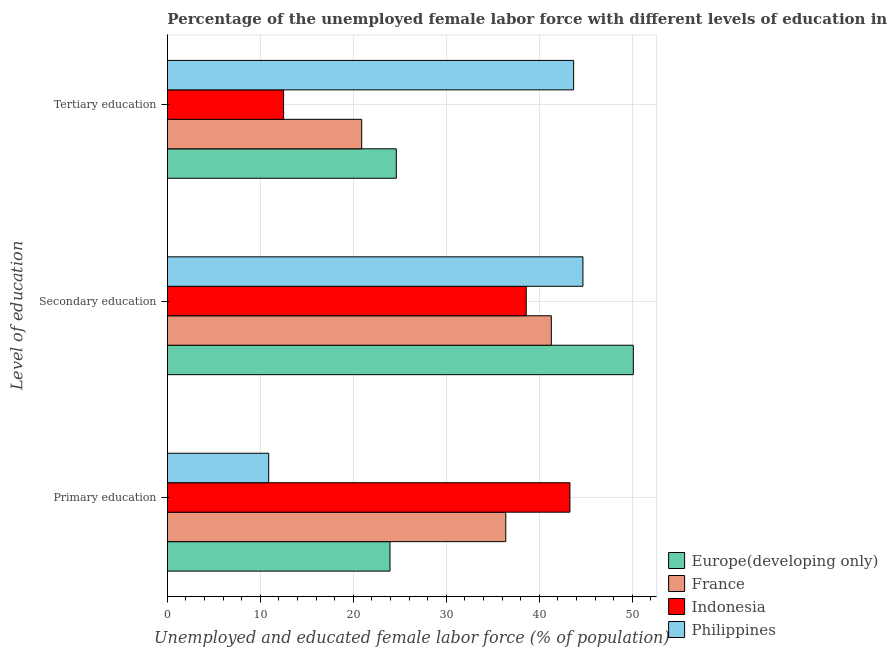Are the number of bars per tick equal to the number of legend labels?
Your answer should be compact. Yes. Are the number of bars on each tick of the Y-axis equal?
Offer a very short reply. Yes. How many bars are there on the 1st tick from the top?
Keep it short and to the point. 4. How many bars are there on the 2nd tick from the bottom?
Provide a short and direct response. 4. What is the label of the 1st group of bars from the top?
Give a very brief answer. Tertiary education. What is the percentage of female labor force who received secondary education in Indonesia?
Give a very brief answer. 38.6. Across all countries, what is the maximum percentage of female labor force who received secondary education?
Your response must be concise. 50.12. Across all countries, what is the minimum percentage of female labor force who received secondary education?
Provide a succinct answer. 38.6. In which country was the percentage of female labor force who received secondary education maximum?
Give a very brief answer. Europe(developing only). In which country was the percentage of female labor force who received tertiary education minimum?
Provide a succinct answer. Indonesia. What is the total percentage of female labor force who received tertiary education in the graph?
Your response must be concise. 101.73. What is the difference between the percentage of female labor force who received tertiary education in France and that in Philippines?
Your answer should be compact. -22.8. What is the difference between the percentage of female labor force who received tertiary education in Philippines and the percentage of female labor force who received secondary education in Indonesia?
Keep it short and to the point. 5.1. What is the average percentage of female labor force who received tertiary education per country?
Give a very brief answer. 25.43. What is the difference between the percentage of female labor force who received primary education and percentage of female labor force who received tertiary education in Philippines?
Offer a very short reply. -32.8. In how many countries, is the percentage of female labor force who received primary education greater than 24 %?
Give a very brief answer. 2. What is the ratio of the percentage of female labor force who received tertiary education in Indonesia to that in Europe(developing only)?
Ensure brevity in your answer.  0.51. Is the percentage of female labor force who received secondary education in Europe(developing only) less than that in France?
Provide a succinct answer. No. What is the difference between the highest and the second highest percentage of female labor force who received primary education?
Offer a terse response. 6.9. What is the difference between the highest and the lowest percentage of female labor force who received primary education?
Ensure brevity in your answer.  32.4. In how many countries, is the percentage of female labor force who received primary education greater than the average percentage of female labor force who received primary education taken over all countries?
Your response must be concise. 2. What does the 2nd bar from the bottom in Tertiary education represents?
Your answer should be compact. France. How many bars are there?
Your answer should be very brief. 12. How many countries are there in the graph?
Your answer should be compact. 4. What is the difference between two consecutive major ticks on the X-axis?
Give a very brief answer. 10. Are the values on the major ticks of X-axis written in scientific E-notation?
Provide a succinct answer. No. How many legend labels are there?
Offer a very short reply. 4. What is the title of the graph?
Provide a short and direct response. Percentage of the unemployed female labor force with different levels of education in countries. Does "Togo" appear as one of the legend labels in the graph?
Make the answer very short. No. What is the label or title of the X-axis?
Your response must be concise. Unemployed and educated female labor force (% of population). What is the label or title of the Y-axis?
Your answer should be compact. Level of education. What is the Unemployed and educated female labor force (% of population) in Europe(developing only) in Primary education?
Offer a terse response. 23.95. What is the Unemployed and educated female labor force (% of population) of France in Primary education?
Give a very brief answer. 36.4. What is the Unemployed and educated female labor force (% of population) of Indonesia in Primary education?
Your answer should be compact. 43.3. What is the Unemployed and educated female labor force (% of population) of Philippines in Primary education?
Your response must be concise. 10.9. What is the Unemployed and educated female labor force (% of population) in Europe(developing only) in Secondary education?
Give a very brief answer. 50.12. What is the Unemployed and educated female labor force (% of population) of France in Secondary education?
Offer a very short reply. 41.3. What is the Unemployed and educated female labor force (% of population) of Indonesia in Secondary education?
Ensure brevity in your answer.  38.6. What is the Unemployed and educated female labor force (% of population) in Philippines in Secondary education?
Your answer should be compact. 44.7. What is the Unemployed and educated female labor force (% of population) of Europe(developing only) in Tertiary education?
Make the answer very short. 24.63. What is the Unemployed and educated female labor force (% of population) in France in Tertiary education?
Your response must be concise. 20.9. What is the Unemployed and educated female labor force (% of population) in Indonesia in Tertiary education?
Provide a short and direct response. 12.5. What is the Unemployed and educated female labor force (% of population) in Philippines in Tertiary education?
Offer a terse response. 43.7. Across all Level of education, what is the maximum Unemployed and educated female labor force (% of population) in Europe(developing only)?
Your answer should be very brief. 50.12. Across all Level of education, what is the maximum Unemployed and educated female labor force (% of population) of France?
Give a very brief answer. 41.3. Across all Level of education, what is the maximum Unemployed and educated female labor force (% of population) of Indonesia?
Make the answer very short. 43.3. Across all Level of education, what is the maximum Unemployed and educated female labor force (% of population) in Philippines?
Ensure brevity in your answer.  44.7. Across all Level of education, what is the minimum Unemployed and educated female labor force (% of population) of Europe(developing only)?
Provide a succinct answer. 23.95. Across all Level of education, what is the minimum Unemployed and educated female labor force (% of population) of France?
Your answer should be very brief. 20.9. Across all Level of education, what is the minimum Unemployed and educated female labor force (% of population) of Philippines?
Make the answer very short. 10.9. What is the total Unemployed and educated female labor force (% of population) of Europe(developing only) in the graph?
Give a very brief answer. 98.69. What is the total Unemployed and educated female labor force (% of population) in France in the graph?
Your answer should be very brief. 98.6. What is the total Unemployed and educated female labor force (% of population) in Indonesia in the graph?
Your answer should be very brief. 94.4. What is the total Unemployed and educated female labor force (% of population) in Philippines in the graph?
Offer a terse response. 99.3. What is the difference between the Unemployed and educated female labor force (% of population) in Europe(developing only) in Primary education and that in Secondary education?
Give a very brief answer. -26.17. What is the difference between the Unemployed and educated female labor force (% of population) in Indonesia in Primary education and that in Secondary education?
Make the answer very short. 4.7. What is the difference between the Unemployed and educated female labor force (% of population) in Philippines in Primary education and that in Secondary education?
Offer a very short reply. -33.8. What is the difference between the Unemployed and educated female labor force (% of population) of Europe(developing only) in Primary education and that in Tertiary education?
Provide a short and direct response. -0.68. What is the difference between the Unemployed and educated female labor force (% of population) in Indonesia in Primary education and that in Tertiary education?
Offer a terse response. 30.8. What is the difference between the Unemployed and educated female labor force (% of population) in Philippines in Primary education and that in Tertiary education?
Your answer should be very brief. -32.8. What is the difference between the Unemployed and educated female labor force (% of population) of Europe(developing only) in Secondary education and that in Tertiary education?
Your response must be concise. 25.49. What is the difference between the Unemployed and educated female labor force (% of population) in France in Secondary education and that in Tertiary education?
Your answer should be compact. 20.4. What is the difference between the Unemployed and educated female labor force (% of population) of Indonesia in Secondary education and that in Tertiary education?
Your response must be concise. 26.1. What is the difference between the Unemployed and educated female labor force (% of population) in Europe(developing only) in Primary education and the Unemployed and educated female labor force (% of population) in France in Secondary education?
Make the answer very short. -17.35. What is the difference between the Unemployed and educated female labor force (% of population) in Europe(developing only) in Primary education and the Unemployed and educated female labor force (% of population) in Indonesia in Secondary education?
Offer a very short reply. -14.65. What is the difference between the Unemployed and educated female labor force (% of population) of Europe(developing only) in Primary education and the Unemployed and educated female labor force (% of population) of Philippines in Secondary education?
Provide a short and direct response. -20.75. What is the difference between the Unemployed and educated female labor force (% of population) of France in Primary education and the Unemployed and educated female labor force (% of population) of Philippines in Secondary education?
Ensure brevity in your answer.  -8.3. What is the difference between the Unemployed and educated female labor force (% of population) of Europe(developing only) in Primary education and the Unemployed and educated female labor force (% of population) of France in Tertiary education?
Provide a short and direct response. 3.05. What is the difference between the Unemployed and educated female labor force (% of population) in Europe(developing only) in Primary education and the Unemployed and educated female labor force (% of population) in Indonesia in Tertiary education?
Give a very brief answer. 11.45. What is the difference between the Unemployed and educated female labor force (% of population) in Europe(developing only) in Primary education and the Unemployed and educated female labor force (% of population) in Philippines in Tertiary education?
Your answer should be compact. -19.75. What is the difference between the Unemployed and educated female labor force (% of population) in France in Primary education and the Unemployed and educated female labor force (% of population) in Indonesia in Tertiary education?
Ensure brevity in your answer.  23.9. What is the difference between the Unemployed and educated female labor force (% of population) of Europe(developing only) in Secondary education and the Unemployed and educated female labor force (% of population) of France in Tertiary education?
Your response must be concise. 29.22. What is the difference between the Unemployed and educated female labor force (% of population) of Europe(developing only) in Secondary education and the Unemployed and educated female labor force (% of population) of Indonesia in Tertiary education?
Your answer should be very brief. 37.62. What is the difference between the Unemployed and educated female labor force (% of population) in Europe(developing only) in Secondary education and the Unemployed and educated female labor force (% of population) in Philippines in Tertiary education?
Give a very brief answer. 6.42. What is the difference between the Unemployed and educated female labor force (% of population) of France in Secondary education and the Unemployed and educated female labor force (% of population) of Indonesia in Tertiary education?
Keep it short and to the point. 28.8. What is the difference between the Unemployed and educated female labor force (% of population) of Indonesia in Secondary education and the Unemployed and educated female labor force (% of population) of Philippines in Tertiary education?
Your answer should be compact. -5.1. What is the average Unemployed and educated female labor force (% of population) in Europe(developing only) per Level of education?
Give a very brief answer. 32.9. What is the average Unemployed and educated female labor force (% of population) of France per Level of education?
Your answer should be compact. 32.87. What is the average Unemployed and educated female labor force (% of population) of Indonesia per Level of education?
Offer a very short reply. 31.47. What is the average Unemployed and educated female labor force (% of population) of Philippines per Level of education?
Offer a terse response. 33.1. What is the difference between the Unemployed and educated female labor force (% of population) in Europe(developing only) and Unemployed and educated female labor force (% of population) in France in Primary education?
Give a very brief answer. -12.45. What is the difference between the Unemployed and educated female labor force (% of population) in Europe(developing only) and Unemployed and educated female labor force (% of population) in Indonesia in Primary education?
Ensure brevity in your answer.  -19.35. What is the difference between the Unemployed and educated female labor force (% of population) in Europe(developing only) and Unemployed and educated female labor force (% of population) in Philippines in Primary education?
Provide a short and direct response. 13.05. What is the difference between the Unemployed and educated female labor force (% of population) in Indonesia and Unemployed and educated female labor force (% of population) in Philippines in Primary education?
Provide a short and direct response. 32.4. What is the difference between the Unemployed and educated female labor force (% of population) in Europe(developing only) and Unemployed and educated female labor force (% of population) in France in Secondary education?
Your answer should be compact. 8.82. What is the difference between the Unemployed and educated female labor force (% of population) in Europe(developing only) and Unemployed and educated female labor force (% of population) in Indonesia in Secondary education?
Keep it short and to the point. 11.52. What is the difference between the Unemployed and educated female labor force (% of population) of Europe(developing only) and Unemployed and educated female labor force (% of population) of Philippines in Secondary education?
Offer a very short reply. 5.42. What is the difference between the Unemployed and educated female labor force (% of population) of France and Unemployed and educated female labor force (% of population) of Indonesia in Secondary education?
Make the answer very short. 2.7. What is the difference between the Unemployed and educated female labor force (% of population) of France and Unemployed and educated female labor force (% of population) of Philippines in Secondary education?
Ensure brevity in your answer.  -3.4. What is the difference between the Unemployed and educated female labor force (% of population) in Indonesia and Unemployed and educated female labor force (% of population) in Philippines in Secondary education?
Make the answer very short. -6.1. What is the difference between the Unemployed and educated female labor force (% of population) of Europe(developing only) and Unemployed and educated female labor force (% of population) of France in Tertiary education?
Your response must be concise. 3.73. What is the difference between the Unemployed and educated female labor force (% of population) of Europe(developing only) and Unemployed and educated female labor force (% of population) of Indonesia in Tertiary education?
Provide a short and direct response. 12.13. What is the difference between the Unemployed and educated female labor force (% of population) in Europe(developing only) and Unemployed and educated female labor force (% of population) in Philippines in Tertiary education?
Your answer should be very brief. -19.07. What is the difference between the Unemployed and educated female labor force (% of population) of France and Unemployed and educated female labor force (% of population) of Indonesia in Tertiary education?
Your response must be concise. 8.4. What is the difference between the Unemployed and educated female labor force (% of population) of France and Unemployed and educated female labor force (% of population) of Philippines in Tertiary education?
Your response must be concise. -22.8. What is the difference between the Unemployed and educated female labor force (% of population) in Indonesia and Unemployed and educated female labor force (% of population) in Philippines in Tertiary education?
Give a very brief answer. -31.2. What is the ratio of the Unemployed and educated female labor force (% of population) in Europe(developing only) in Primary education to that in Secondary education?
Give a very brief answer. 0.48. What is the ratio of the Unemployed and educated female labor force (% of population) in France in Primary education to that in Secondary education?
Your answer should be compact. 0.88. What is the ratio of the Unemployed and educated female labor force (% of population) of Indonesia in Primary education to that in Secondary education?
Ensure brevity in your answer.  1.12. What is the ratio of the Unemployed and educated female labor force (% of population) in Philippines in Primary education to that in Secondary education?
Offer a very short reply. 0.24. What is the ratio of the Unemployed and educated female labor force (% of population) of Europe(developing only) in Primary education to that in Tertiary education?
Provide a succinct answer. 0.97. What is the ratio of the Unemployed and educated female labor force (% of population) in France in Primary education to that in Tertiary education?
Your response must be concise. 1.74. What is the ratio of the Unemployed and educated female labor force (% of population) of Indonesia in Primary education to that in Tertiary education?
Offer a terse response. 3.46. What is the ratio of the Unemployed and educated female labor force (% of population) in Philippines in Primary education to that in Tertiary education?
Your answer should be compact. 0.25. What is the ratio of the Unemployed and educated female labor force (% of population) of Europe(developing only) in Secondary education to that in Tertiary education?
Keep it short and to the point. 2.04. What is the ratio of the Unemployed and educated female labor force (% of population) of France in Secondary education to that in Tertiary education?
Give a very brief answer. 1.98. What is the ratio of the Unemployed and educated female labor force (% of population) in Indonesia in Secondary education to that in Tertiary education?
Offer a very short reply. 3.09. What is the ratio of the Unemployed and educated female labor force (% of population) in Philippines in Secondary education to that in Tertiary education?
Your answer should be compact. 1.02. What is the difference between the highest and the second highest Unemployed and educated female labor force (% of population) in Europe(developing only)?
Provide a short and direct response. 25.49. What is the difference between the highest and the lowest Unemployed and educated female labor force (% of population) in Europe(developing only)?
Your answer should be very brief. 26.17. What is the difference between the highest and the lowest Unemployed and educated female labor force (% of population) of France?
Give a very brief answer. 20.4. What is the difference between the highest and the lowest Unemployed and educated female labor force (% of population) of Indonesia?
Provide a succinct answer. 30.8. What is the difference between the highest and the lowest Unemployed and educated female labor force (% of population) of Philippines?
Your answer should be very brief. 33.8. 